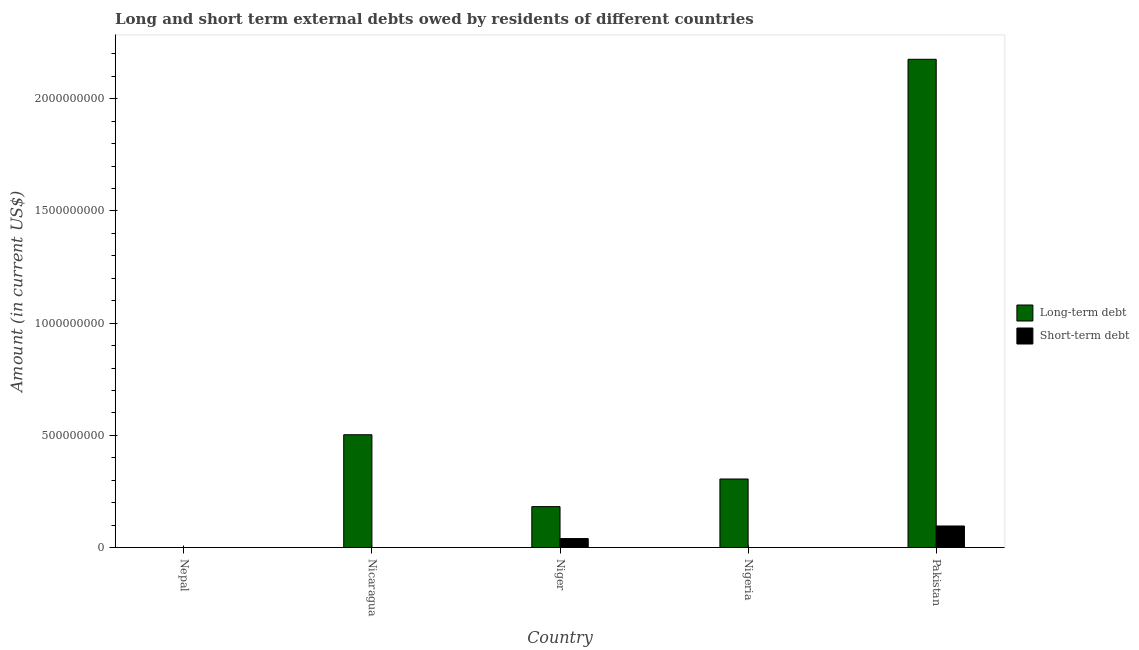Are the number of bars on each tick of the X-axis equal?
Your response must be concise. No. How many bars are there on the 1st tick from the right?
Offer a very short reply. 2. What is the label of the 2nd group of bars from the left?
Give a very brief answer. Nicaragua. What is the short-term debts owed by residents in Nicaragua?
Provide a short and direct response. 0. Across all countries, what is the maximum long-term debts owed by residents?
Ensure brevity in your answer.  2.18e+09. In which country was the short-term debts owed by residents maximum?
Your answer should be very brief. Pakistan. What is the total short-term debts owed by residents in the graph?
Provide a succinct answer. 1.36e+08. What is the difference between the long-term debts owed by residents in Nicaragua and that in Nigeria?
Your answer should be compact. 1.97e+08. What is the difference between the short-term debts owed by residents in Niger and the long-term debts owed by residents in Nepal?
Your answer should be compact. 4.00e+07. What is the average long-term debts owed by residents per country?
Your response must be concise. 6.33e+08. What is the difference between the long-term debts owed by residents and short-term debts owed by residents in Niger?
Your answer should be compact. 1.42e+08. In how many countries, is the short-term debts owed by residents greater than 700000000 US$?
Provide a succinct answer. 0. Is the long-term debts owed by residents in Nigeria less than that in Pakistan?
Give a very brief answer. Yes. What is the difference between the highest and the second highest long-term debts owed by residents?
Provide a succinct answer. 1.67e+09. What is the difference between the highest and the lowest long-term debts owed by residents?
Offer a very short reply. 2.18e+09. Is the sum of the long-term debts owed by residents in Nicaragua and Nigeria greater than the maximum short-term debts owed by residents across all countries?
Your answer should be compact. Yes. How many bars are there?
Your answer should be compact. 6. What is the difference between two consecutive major ticks on the Y-axis?
Make the answer very short. 5.00e+08. Does the graph contain grids?
Ensure brevity in your answer.  No. How are the legend labels stacked?
Offer a very short reply. Vertical. What is the title of the graph?
Your answer should be compact. Long and short term external debts owed by residents of different countries. What is the Amount (in current US$) of Long-term debt in Nicaragua?
Make the answer very short. 5.03e+08. What is the Amount (in current US$) in Long-term debt in Niger?
Your answer should be compact. 1.82e+08. What is the Amount (in current US$) of Short-term debt in Niger?
Your answer should be very brief. 4.00e+07. What is the Amount (in current US$) of Long-term debt in Nigeria?
Offer a terse response. 3.05e+08. What is the Amount (in current US$) of Short-term debt in Nigeria?
Offer a terse response. 0. What is the Amount (in current US$) in Long-term debt in Pakistan?
Your answer should be compact. 2.18e+09. What is the Amount (in current US$) of Short-term debt in Pakistan?
Make the answer very short. 9.60e+07. Across all countries, what is the maximum Amount (in current US$) in Long-term debt?
Your answer should be compact. 2.18e+09. Across all countries, what is the maximum Amount (in current US$) in Short-term debt?
Make the answer very short. 9.60e+07. Across all countries, what is the minimum Amount (in current US$) of Long-term debt?
Offer a terse response. 0. What is the total Amount (in current US$) in Long-term debt in the graph?
Provide a short and direct response. 3.17e+09. What is the total Amount (in current US$) of Short-term debt in the graph?
Provide a succinct answer. 1.36e+08. What is the difference between the Amount (in current US$) of Long-term debt in Nicaragua and that in Niger?
Keep it short and to the point. 3.20e+08. What is the difference between the Amount (in current US$) in Long-term debt in Nicaragua and that in Nigeria?
Give a very brief answer. 1.97e+08. What is the difference between the Amount (in current US$) in Long-term debt in Nicaragua and that in Pakistan?
Offer a very short reply. -1.67e+09. What is the difference between the Amount (in current US$) of Long-term debt in Niger and that in Nigeria?
Offer a very short reply. -1.23e+08. What is the difference between the Amount (in current US$) in Long-term debt in Niger and that in Pakistan?
Offer a terse response. -1.99e+09. What is the difference between the Amount (in current US$) of Short-term debt in Niger and that in Pakistan?
Make the answer very short. -5.60e+07. What is the difference between the Amount (in current US$) in Long-term debt in Nigeria and that in Pakistan?
Provide a short and direct response. -1.87e+09. What is the difference between the Amount (in current US$) of Long-term debt in Nicaragua and the Amount (in current US$) of Short-term debt in Niger?
Ensure brevity in your answer.  4.63e+08. What is the difference between the Amount (in current US$) in Long-term debt in Nicaragua and the Amount (in current US$) in Short-term debt in Pakistan?
Your response must be concise. 4.07e+08. What is the difference between the Amount (in current US$) in Long-term debt in Niger and the Amount (in current US$) in Short-term debt in Pakistan?
Make the answer very short. 8.63e+07. What is the difference between the Amount (in current US$) in Long-term debt in Nigeria and the Amount (in current US$) in Short-term debt in Pakistan?
Your response must be concise. 2.09e+08. What is the average Amount (in current US$) of Long-term debt per country?
Your answer should be compact. 6.33e+08. What is the average Amount (in current US$) in Short-term debt per country?
Offer a terse response. 2.72e+07. What is the difference between the Amount (in current US$) in Long-term debt and Amount (in current US$) in Short-term debt in Niger?
Offer a terse response. 1.42e+08. What is the difference between the Amount (in current US$) of Long-term debt and Amount (in current US$) of Short-term debt in Pakistan?
Make the answer very short. 2.08e+09. What is the ratio of the Amount (in current US$) in Long-term debt in Nicaragua to that in Niger?
Keep it short and to the point. 2.76. What is the ratio of the Amount (in current US$) of Long-term debt in Nicaragua to that in Nigeria?
Keep it short and to the point. 1.65. What is the ratio of the Amount (in current US$) of Long-term debt in Nicaragua to that in Pakistan?
Your response must be concise. 0.23. What is the ratio of the Amount (in current US$) in Long-term debt in Niger to that in Nigeria?
Your response must be concise. 0.6. What is the ratio of the Amount (in current US$) in Long-term debt in Niger to that in Pakistan?
Your answer should be very brief. 0.08. What is the ratio of the Amount (in current US$) in Short-term debt in Niger to that in Pakistan?
Provide a succinct answer. 0.42. What is the ratio of the Amount (in current US$) in Long-term debt in Nigeria to that in Pakistan?
Provide a succinct answer. 0.14. What is the difference between the highest and the second highest Amount (in current US$) in Long-term debt?
Your answer should be compact. 1.67e+09. What is the difference between the highest and the lowest Amount (in current US$) in Long-term debt?
Keep it short and to the point. 2.18e+09. What is the difference between the highest and the lowest Amount (in current US$) of Short-term debt?
Provide a succinct answer. 9.60e+07. 